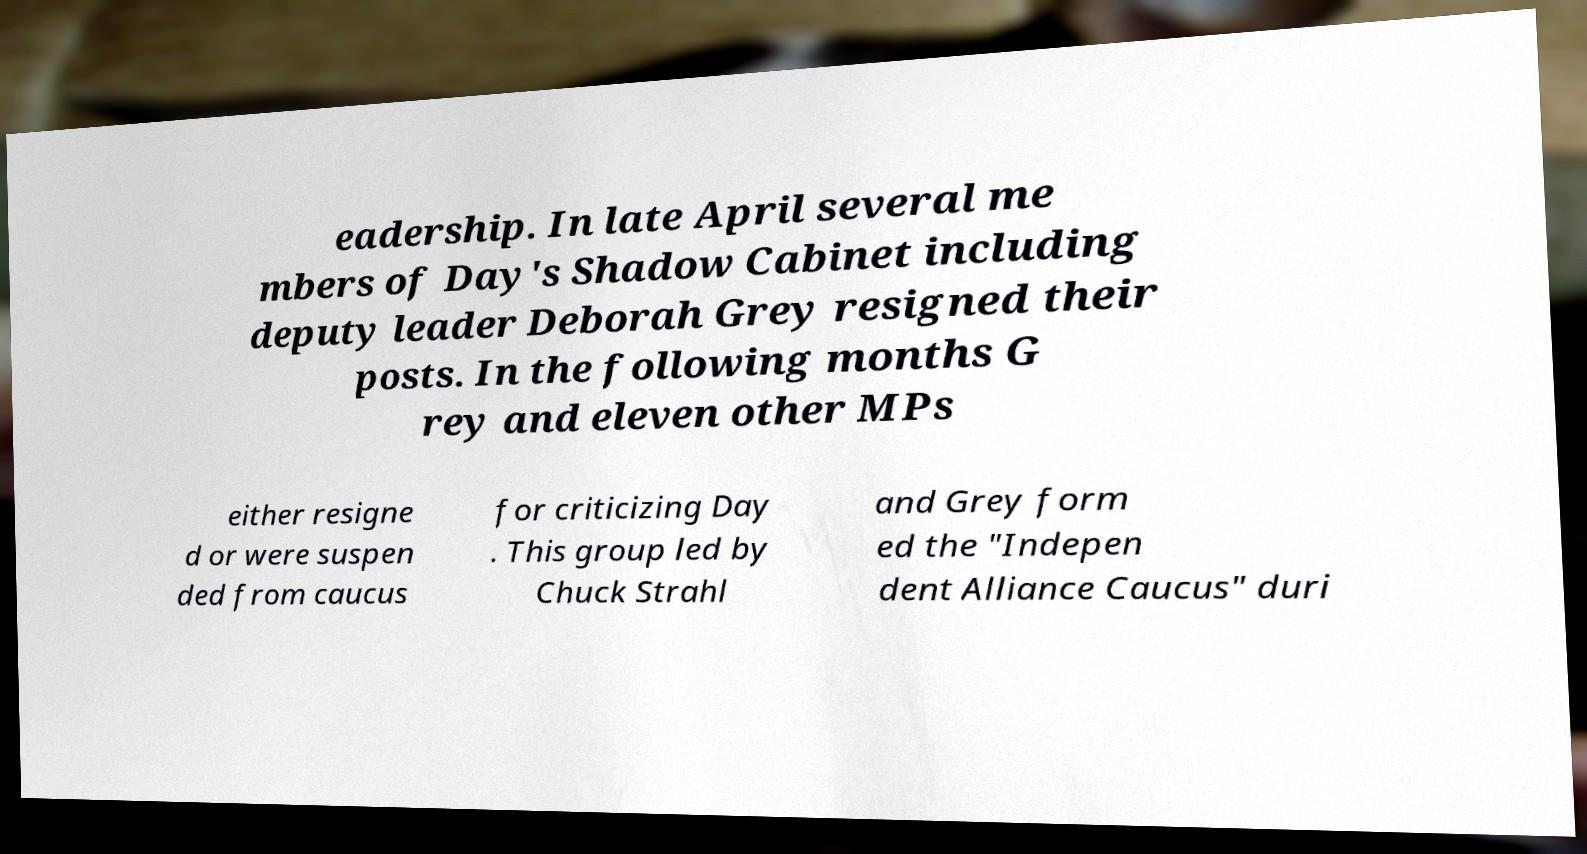I need the written content from this picture converted into text. Can you do that? eadership. In late April several me mbers of Day's Shadow Cabinet including deputy leader Deborah Grey resigned their posts. In the following months G rey and eleven other MPs either resigne d or were suspen ded from caucus for criticizing Day . This group led by Chuck Strahl and Grey form ed the "Indepen dent Alliance Caucus" duri 